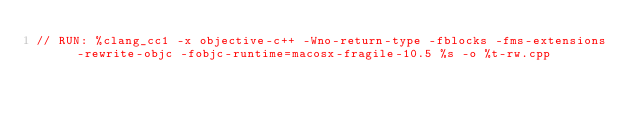<code> <loc_0><loc_0><loc_500><loc_500><_ObjectiveC_>// RUN: %clang_cc1 -x objective-c++ -Wno-return-type -fblocks -fms-extensions -rewrite-objc -fobjc-runtime=macosx-fragile-10.5 %s -o %t-rw.cpp</code> 